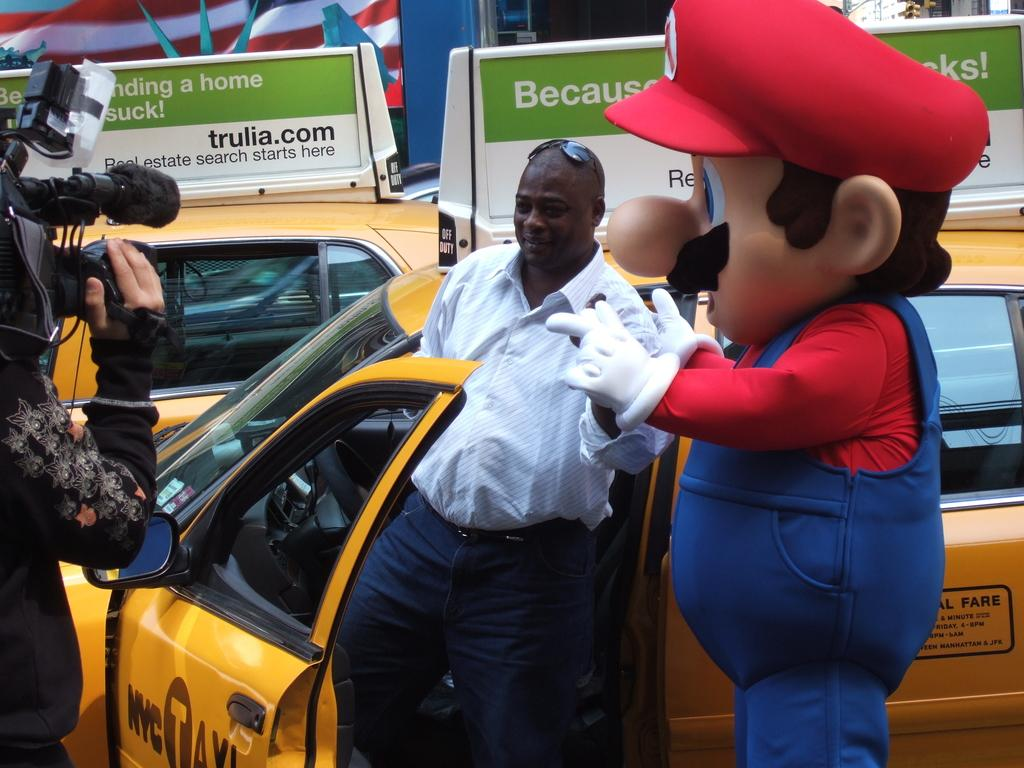<image>
Write a terse but informative summary of the picture. Mario accosting a NYC Taxi driver while a camera films it. 